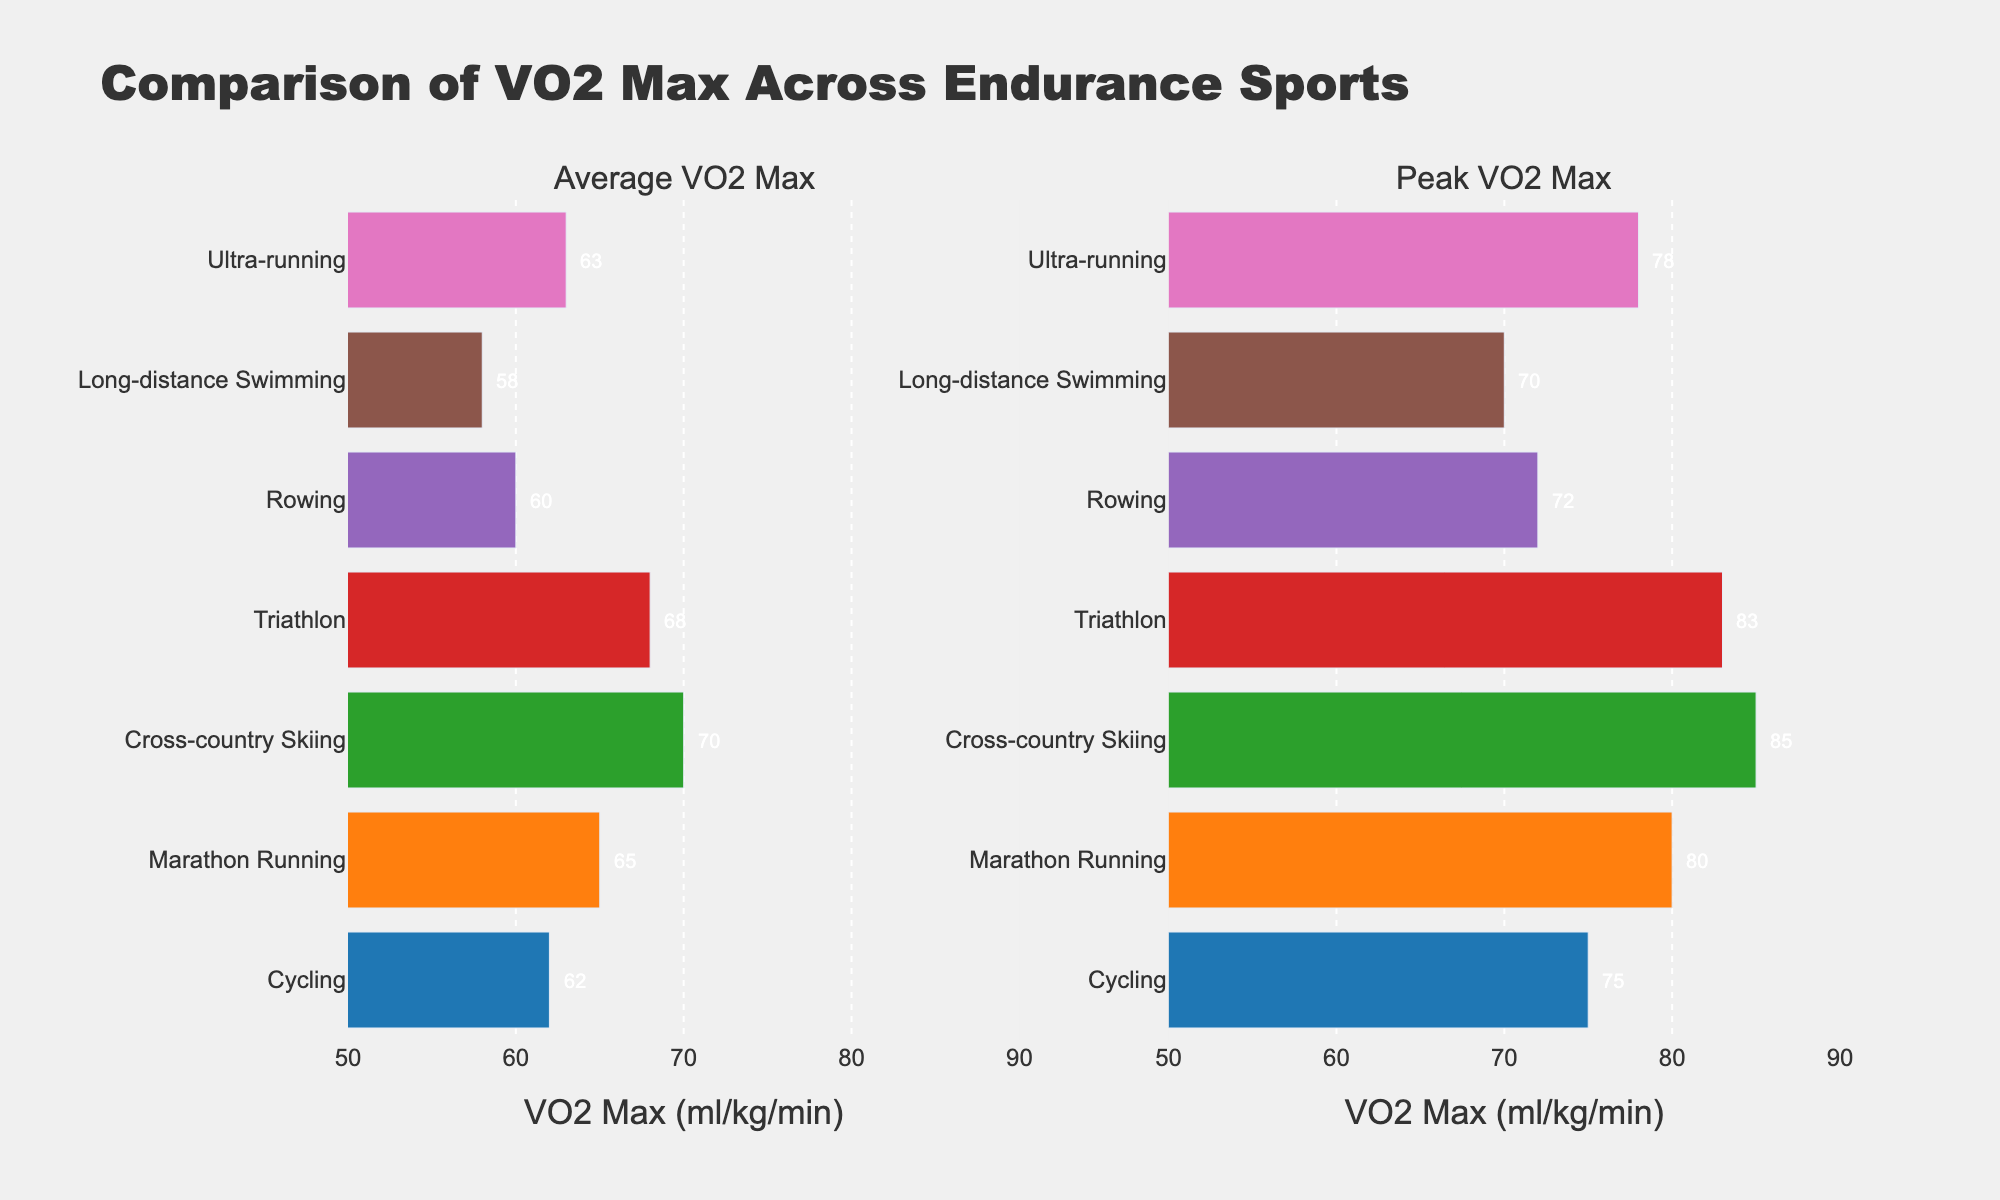What's the title of the figure? The title of the figure is displayed at the top, in a larger and bold font, making it easily identifiable.
Answer: Comparison of VO2 Max Across Endurance Sports How many sports are compared in the figure? By counting the unique sports on the y-axis in either of the subplots, we can determine the number of sports compared.
Answer: 7 Which sport has the highest Average VO2 Max? By looking at the 'Average VO2 Max' horizontal bars, the longest bar represents the sport with the highest value.
Answer: Cross-country Skiing What is the difference between the Peak and Average VO2 Max for Marathon Runners? First, find the Peak VO2 Max (80 ml/kg/min) and the Average VO2 Max (65 ml/kg/min) for Marathon Running and then subtract the Average from the Peak.
Answer: 15 ml/kg/min Between Marathon Running and Triathlon, which sport has a higher Peak VO2 Max? Compare the Peak VO2 Max bars of Marathon Running and Triathlon in the right subplot.
Answer: Marathon Running What is the range of Average VO2 Max values across all sports? Identify the smallest (58) and largest (70) Average VO2 Max values from the plot and find the range by subtracting the smallest from the largest.
Answer: 12 ml/kg/min Which sport has the smallest gap between Peak and Average VO2 Max? For each sport, calculate the difference between Peak and Average VO2 Max values and identify the sport with the smallest difference.
Answer: Rowing Rank the sports from highest to lowest based on their Average VO2 Max. Arrange the sports in descending order of their Average VO2 Max, which can be observed by the length of the bars in the first subplot.
Answer: Cross-country Skiing, Triathlon, Marathon Running, Ultra-running, Cycling, Rowing, Long-distance Swimming Do all sports show a higher Peak VO2 Max compared to their Average VO2 Max? Check if the Peak VO2 Max bars in the second subplot are longer than their corresponding Average VO2 Max bars in the first subplot for all sports.
Answer: Yes 